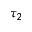<formula> <loc_0><loc_0><loc_500><loc_500>\tau _ { 2 }</formula> 